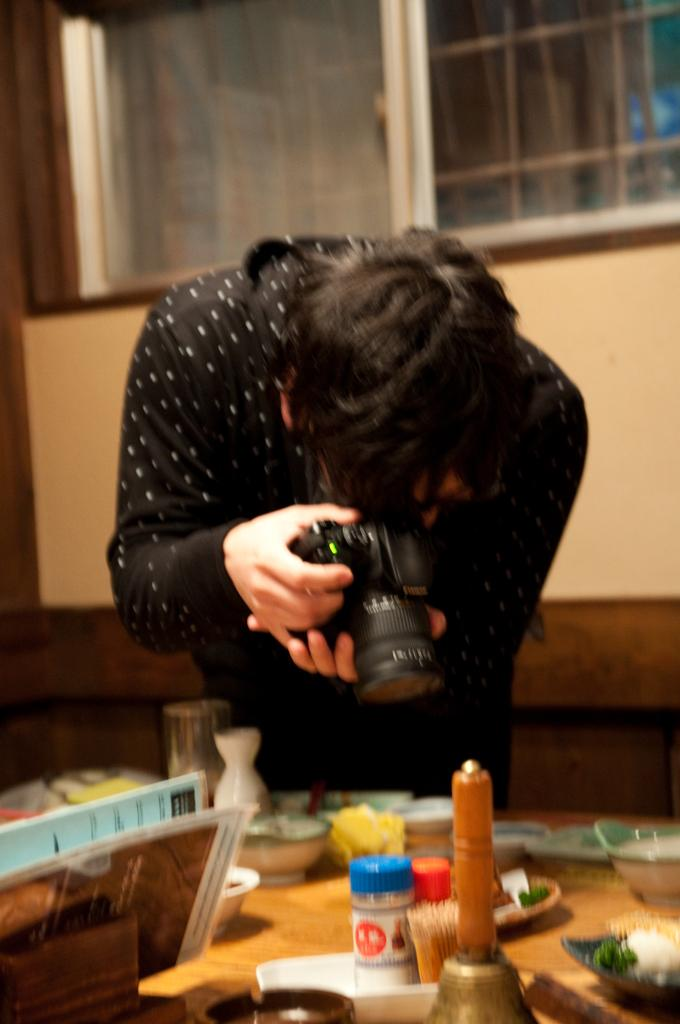Who is the main subject in the image? There is a person in the image. What is the person holding in the image? The person is holding a camera. What is the purpose of the camera in the image? The camera is being used to take a photograph. What other objects can be seen in the image? There is a table in the image, and it has various items on it. What type of brass instrument is the person playing in the image? There is no brass instrument present in the image; the person is holding a camera. 